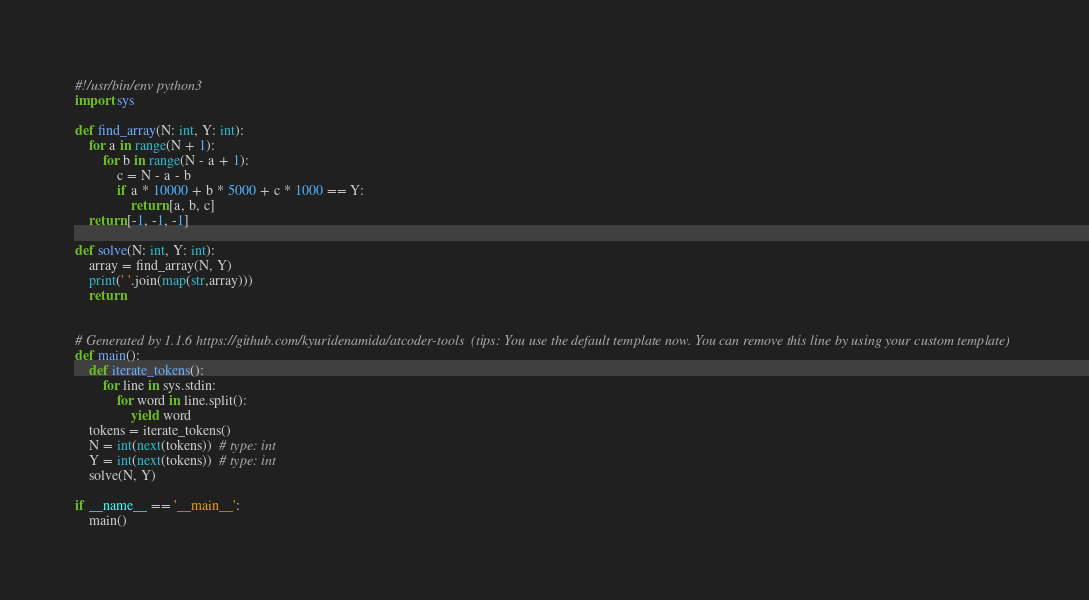<code> <loc_0><loc_0><loc_500><loc_500><_Python_>#!/usr/bin/env python3
import sys
 
def find_array(N: int, Y: int):
    for a in range(N + 1):
        for b in range(N - a + 1):
            c = N - a - b
            if a * 10000 + b * 5000 + c * 1000 == Y:
                return [a, b, c]
    return [-1, -1, -1]
 
def solve(N: int, Y: int):
    array = find_array(N, Y)
    print(' '.join(map(str,array)))
    return
 
 
# Generated by 1.1.6 https://github.com/kyuridenamida/atcoder-tools  (tips: You use the default template now. You can remove this line by using your custom template)
def main():
    def iterate_tokens():
        for line in sys.stdin:
            for word in line.split():
                yield word
    tokens = iterate_tokens()
    N = int(next(tokens))  # type: int
    Y = int(next(tokens))  # type: int
    solve(N, Y)
 
if __name__ == '__main__':
    main()</code> 